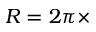Convert formula to latex. <formula><loc_0><loc_0><loc_500><loc_500>R = 2 \pi \times</formula> 